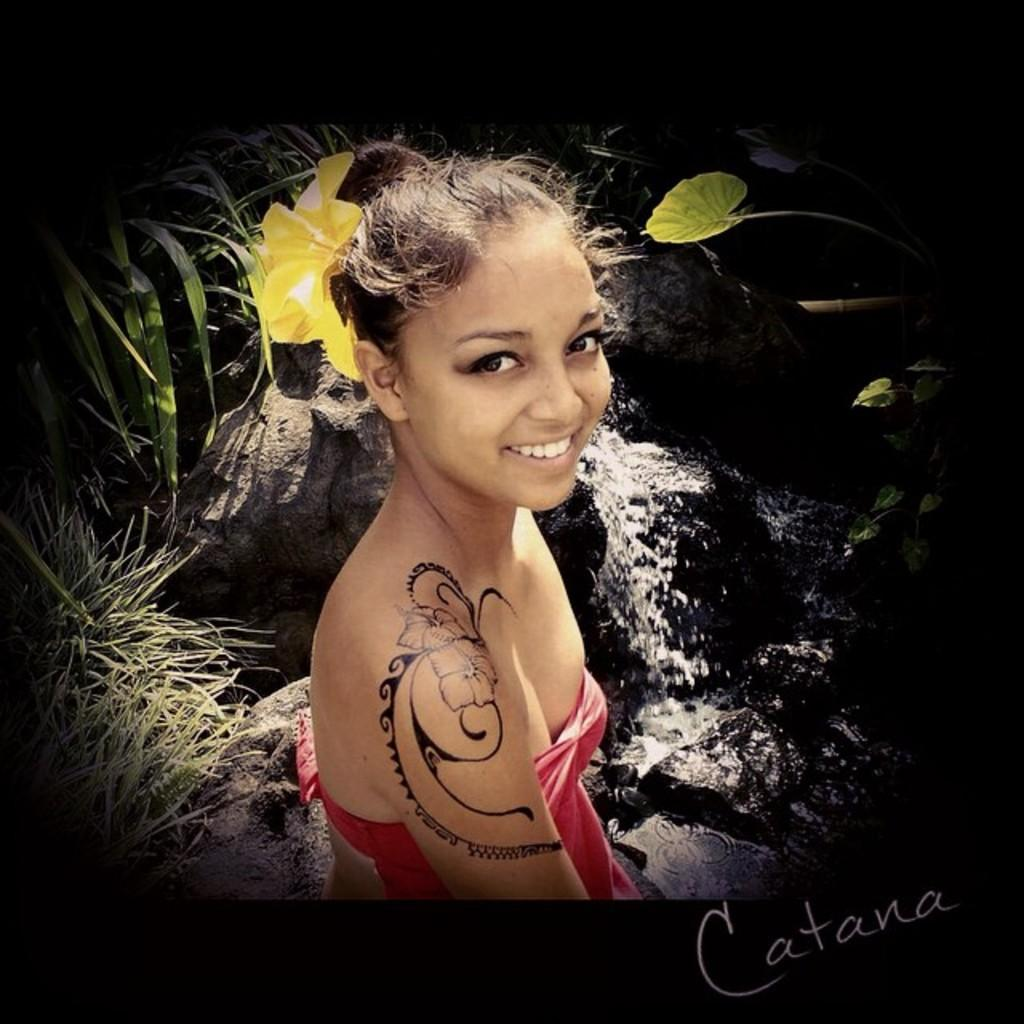What is depicted on the poster? The poster has an image that contains grass, plants, rocks, and a waterfall. What type of natural features are present in the image? The image contains grass, plants, rocks, and a waterfall. Is there any text or additional elements on the poster? Yes, there is a watermark on the poster. How would you describe the background color of the poster? The background of the poster is dark in color. How many legs can be seen on the pan in the image? There is no pan present in the image, so it is not possible to determine the number of legs. 